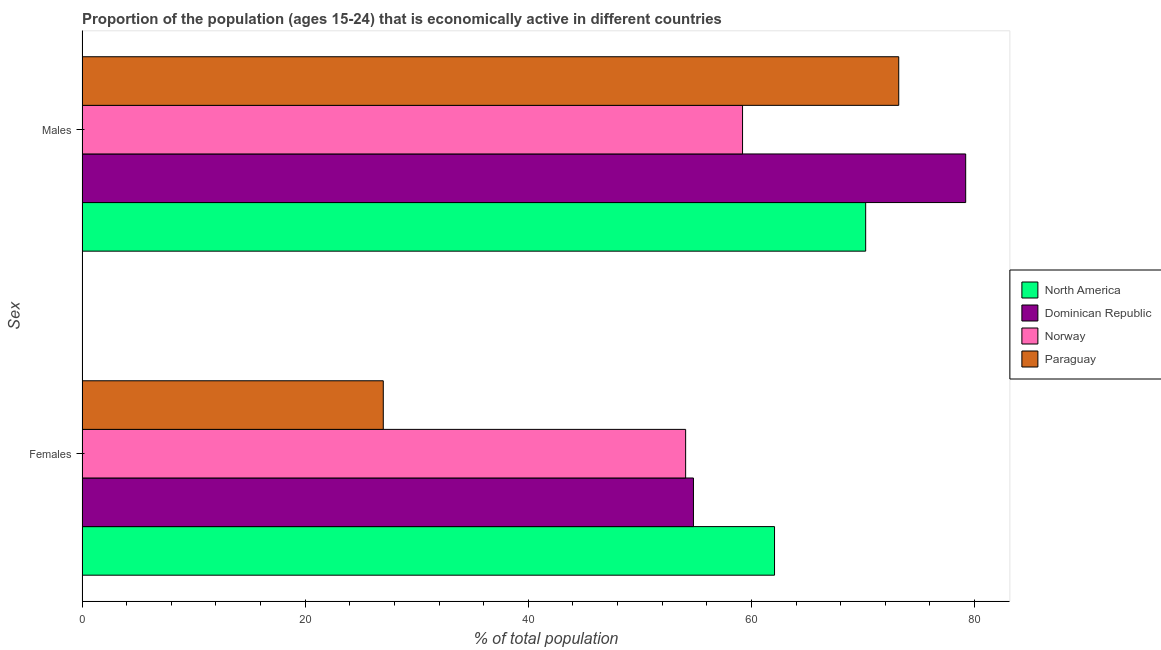Are the number of bars per tick equal to the number of legend labels?
Make the answer very short. Yes. Are the number of bars on each tick of the Y-axis equal?
Provide a succinct answer. Yes. How many bars are there on the 2nd tick from the top?
Provide a short and direct response. 4. How many bars are there on the 2nd tick from the bottom?
Make the answer very short. 4. What is the label of the 1st group of bars from the top?
Make the answer very short. Males. What is the percentage of economically active male population in North America?
Give a very brief answer. 70.24. Across all countries, what is the maximum percentage of economically active male population?
Offer a very short reply. 79.2. Across all countries, what is the minimum percentage of economically active male population?
Make the answer very short. 59.2. In which country was the percentage of economically active male population minimum?
Your response must be concise. Norway. What is the total percentage of economically active male population in the graph?
Provide a short and direct response. 281.84. What is the difference between the percentage of economically active male population in Paraguay and that in Norway?
Give a very brief answer. 14. What is the difference between the percentage of economically active female population in Norway and the percentage of economically active male population in Dominican Republic?
Give a very brief answer. -25.1. What is the average percentage of economically active female population per country?
Offer a very short reply. 49.49. What is the difference between the percentage of economically active female population and percentage of economically active male population in Norway?
Ensure brevity in your answer.  -5.1. What is the ratio of the percentage of economically active male population in Dominican Republic to that in Norway?
Your response must be concise. 1.34. In how many countries, is the percentage of economically active female population greater than the average percentage of economically active female population taken over all countries?
Give a very brief answer. 3. What does the 4th bar from the bottom in Females represents?
Make the answer very short. Paraguay. How many bars are there?
Give a very brief answer. 8. Are all the bars in the graph horizontal?
Offer a terse response. Yes. Are the values on the major ticks of X-axis written in scientific E-notation?
Ensure brevity in your answer.  No. Does the graph contain grids?
Keep it short and to the point. No. How many legend labels are there?
Provide a succinct answer. 4. What is the title of the graph?
Give a very brief answer. Proportion of the population (ages 15-24) that is economically active in different countries. What is the label or title of the X-axis?
Provide a succinct answer. % of total population. What is the label or title of the Y-axis?
Ensure brevity in your answer.  Sex. What is the % of total population in North America in Females?
Offer a very short reply. 62.07. What is the % of total population of Dominican Republic in Females?
Give a very brief answer. 54.8. What is the % of total population of Norway in Females?
Provide a succinct answer. 54.1. What is the % of total population in North America in Males?
Provide a short and direct response. 70.24. What is the % of total population in Dominican Republic in Males?
Provide a succinct answer. 79.2. What is the % of total population in Norway in Males?
Your answer should be very brief. 59.2. What is the % of total population in Paraguay in Males?
Offer a very short reply. 73.2. Across all Sex, what is the maximum % of total population in North America?
Provide a succinct answer. 70.24. Across all Sex, what is the maximum % of total population in Dominican Republic?
Your answer should be very brief. 79.2. Across all Sex, what is the maximum % of total population in Norway?
Your answer should be very brief. 59.2. Across all Sex, what is the maximum % of total population of Paraguay?
Offer a very short reply. 73.2. Across all Sex, what is the minimum % of total population in North America?
Your answer should be very brief. 62.07. Across all Sex, what is the minimum % of total population in Dominican Republic?
Offer a terse response. 54.8. Across all Sex, what is the minimum % of total population of Norway?
Your answer should be very brief. 54.1. Across all Sex, what is the minimum % of total population in Paraguay?
Keep it short and to the point. 27. What is the total % of total population in North America in the graph?
Provide a short and direct response. 132.3. What is the total % of total population of Dominican Republic in the graph?
Provide a short and direct response. 134. What is the total % of total population in Norway in the graph?
Provide a short and direct response. 113.3. What is the total % of total population of Paraguay in the graph?
Offer a terse response. 100.2. What is the difference between the % of total population of North America in Females and that in Males?
Give a very brief answer. -8.17. What is the difference between the % of total population of Dominican Republic in Females and that in Males?
Offer a very short reply. -24.4. What is the difference between the % of total population of Norway in Females and that in Males?
Keep it short and to the point. -5.1. What is the difference between the % of total population of Paraguay in Females and that in Males?
Provide a short and direct response. -46.2. What is the difference between the % of total population in North America in Females and the % of total population in Dominican Republic in Males?
Your response must be concise. -17.13. What is the difference between the % of total population of North America in Females and the % of total population of Norway in Males?
Your response must be concise. 2.87. What is the difference between the % of total population of North America in Females and the % of total population of Paraguay in Males?
Your response must be concise. -11.13. What is the difference between the % of total population in Dominican Republic in Females and the % of total population in Paraguay in Males?
Make the answer very short. -18.4. What is the difference between the % of total population in Norway in Females and the % of total population in Paraguay in Males?
Keep it short and to the point. -19.1. What is the average % of total population in North America per Sex?
Provide a succinct answer. 66.15. What is the average % of total population in Norway per Sex?
Provide a succinct answer. 56.65. What is the average % of total population of Paraguay per Sex?
Your answer should be very brief. 50.1. What is the difference between the % of total population of North America and % of total population of Dominican Republic in Females?
Your response must be concise. 7.27. What is the difference between the % of total population in North America and % of total population in Norway in Females?
Give a very brief answer. 7.97. What is the difference between the % of total population of North America and % of total population of Paraguay in Females?
Keep it short and to the point. 35.07. What is the difference between the % of total population of Dominican Republic and % of total population of Norway in Females?
Your answer should be very brief. 0.7. What is the difference between the % of total population of Dominican Republic and % of total population of Paraguay in Females?
Keep it short and to the point. 27.8. What is the difference between the % of total population of Norway and % of total population of Paraguay in Females?
Make the answer very short. 27.1. What is the difference between the % of total population in North America and % of total population in Dominican Republic in Males?
Your response must be concise. -8.96. What is the difference between the % of total population in North America and % of total population in Norway in Males?
Provide a short and direct response. 11.04. What is the difference between the % of total population in North America and % of total population in Paraguay in Males?
Provide a short and direct response. -2.96. What is the difference between the % of total population of Dominican Republic and % of total population of Norway in Males?
Offer a terse response. 20. What is the ratio of the % of total population of North America in Females to that in Males?
Your answer should be compact. 0.88. What is the ratio of the % of total population in Dominican Republic in Females to that in Males?
Make the answer very short. 0.69. What is the ratio of the % of total population of Norway in Females to that in Males?
Provide a short and direct response. 0.91. What is the ratio of the % of total population in Paraguay in Females to that in Males?
Give a very brief answer. 0.37. What is the difference between the highest and the second highest % of total population in North America?
Ensure brevity in your answer.  8.17. What is the difference between the highest and the second highest % of total population of Dominican Republic?
Your response must be concise. 24.4. What is the difference between the highest and the second highest % of total population of Norway?
Offer a very short reply. 5.1. What is the difference between the highest and the second highest % of total population in Paraguay?
Your answer should be very brief. 46.2. What is the difference between the highest and the lowest % of total population of North America?
Your answer should be very brief. 8.17. What is the difference between the highest and the lowest % of total population in Dominican Republic?
Give a very brief answer. 24.4. What is the difference between the highest and the lowest % of total population in Norway?
Keep it short and to the point. 5.1. What is the difference between the highest and the lowest % of total population in Paraguay?
Make the answer very short. 46.2. 